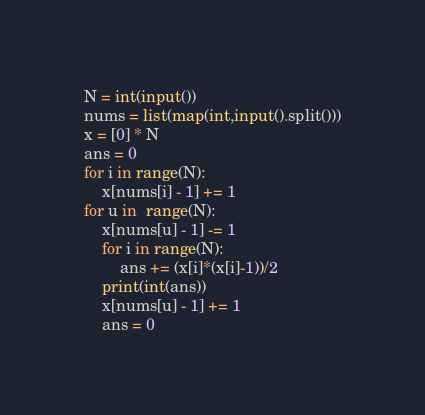Convert code to text. <code><loc_0><loc_0><loc_500><loc_500><_Python_>N = int(input())
nums = list(map(int,input().split()))
x = [0] * N
ans = 0
for i in range(N):
    x[nums[i] - 1] += 1
for u in  range(N):
    x[nums[u] - 1] -= 1
    for i in range(N):
        ans += (x[i]*(x[i]-1))/2
    print(int(ans))
    x[nums[u] - 1] += 1
    ans = 0</code> 